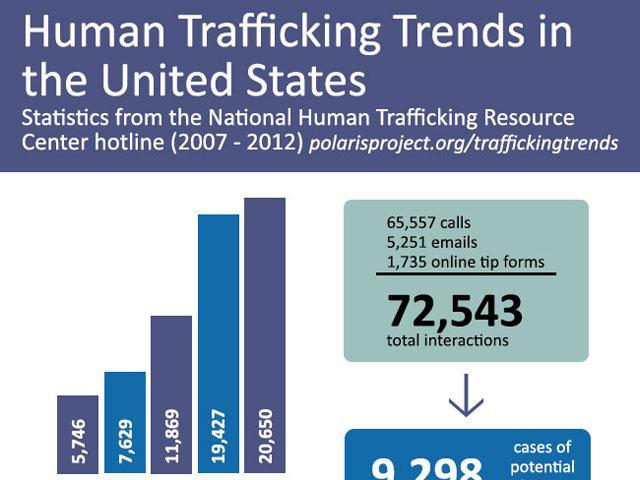how many mails and calls
Answer the question with a short phrase. 70808 in interactions, count from which was the lowest online tip forms what is the difference between the largest and smallest value in the bar chart 14904 what is the second highest number in the bar chart 19427 